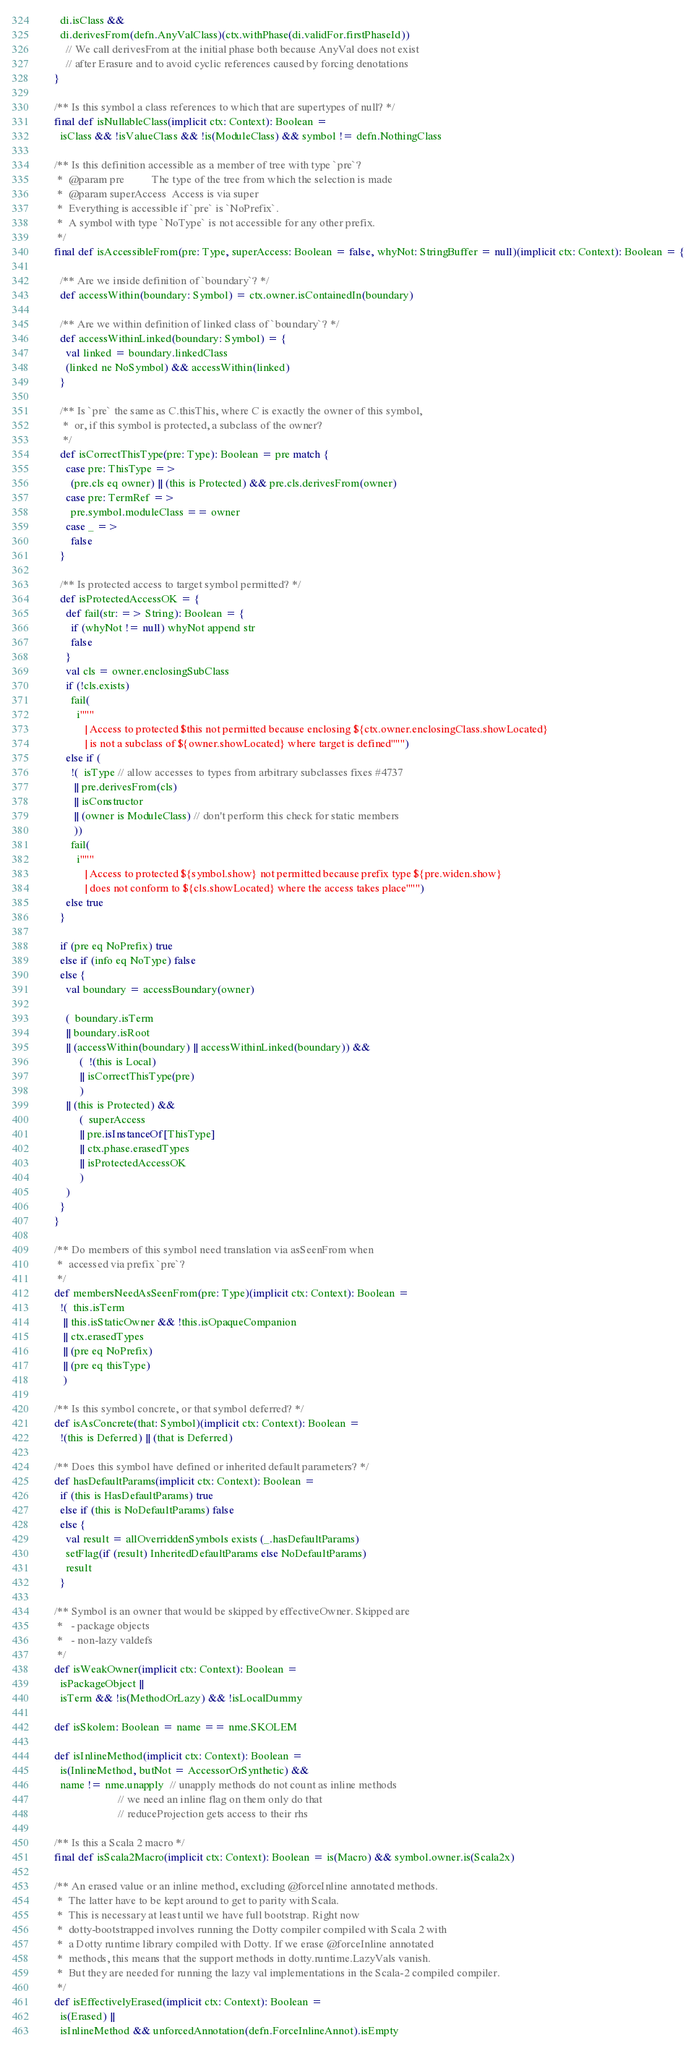Convert code to text. <code><loc_0><loc_0><loc_500><loc_500><_Scala_>      di.isClass &&
      di.derivesFrom(defn.AnyValClass)(ctx.withPhase(di.validFor.firstPhaseId))
        // We call derivesFrom at the initial phase both because AnyVal does not exist
        // after Erasure and to avoid cyclic references caused by forcing denotations
    }

    /** Is this symbol a class references to which that are supertypes of null? */
    final def isNullableClass(implicit ctx: Context): Boolean =
      isClass && !isValueClass && !is(ModuleClass) && symbol != defn.NothingClass

    /** Is this definition accessible as a member of tree with type `pre`?
     *  @param pre          The type of the tree from which the selection is made
     *  @param superAccess  Access is via super
     *  Everything is accessible if `pre` is `NoPrefix`.
     *  A symbol with type `NoType` is not accessible for any other prefix.
     */
    final def isAccessibleFrom(pre: Type, superAccess: Boolean = false, whyNot: StringBuffer = null)(implicit ctx: Context): Boolean = {

      /** Are we inside definition of `boundary`? */
      def accessWithin(boundary: Symbol) = ctx.owner.isContainedIn(boundary)

      /** Are we within definition of linked class of `boundary`? */
      def accessWithinLinked(boundary: Symbol) = {
        val linked = boundary.linkedClass
        (linked ne NoSymbol) && accessWithin(linked)
      }

      /** Is `pre` the same as C.thisThis, where C is exactly the owner of this symbol,
       *  or, if this symbol is protected, a subclass of the owner?
       */
      def isCorrectThisType(pre: Type): Boolean = pre match {
        case pre: ThisType =>
          (pre.cls eq owner) || (this is Protected) && pre.cls.derivesFrom(owner)
        case pre: TermRef =>
          pre.symbol.moduleClass == owner
        case _ =>
          false
      }

      /** Is protected access to target symbol permitted? */
      def isProtectedAccessOK = {
        def fail(str: => String): Boolean = {
          if (whyNot != null) whyNot append str
          false
        }
        val cls = owner.enclosingSubClass
        if (!cls.exists)
          fail(
            i"""
               | Access to protected $this not permitted because enclosing ${ctx.owner.enclosingClass.showLocated}
               | is not a subclass of ${owner.showLocated} where target is defined""")
        else if (
          !(  isType // allow accesses to types from arbitrary subclasses fixes #4737
           || pre.derivesFrom(cls)
           || isConstructor
           || (owner is ModuleClass) // don't perform this check for static members
           ))
          fail(
            i"""
               | Access to protected ${symbol.show} not permitted because prefix type ${pre.widen.show}
               | does not conform to ${cls.showLocated} where the access takes place""")
        else true
      }

      if (pre eq NoPrefix) true
      else if (info eq NoType) false
      else {
        val boundary = accessBoundary(owner)

        (  boundary.isTerm
        || boundary.isRoot
        || (accessWithin(boundary) || accessWithinLinked(boundary)) &&
             (  !(this is Local)
             || isCorrectThisType(pre)
             )
        || (this is Protected) &&
             (  superAccess
             || pre.isInstanceOf[ThisType]
             || ctx.phase.erasedTypes
             || isProtectedAccessOK
             )
        )
      }
    }

    /** Do members of this symbol need translation via asSeenFrom when
     *  accessed via prefix `pre`?
     */
    def membersNeedAsSeenFrom(pre: Type)(implicit ctx: Context): Boolean =
      !(  this.isTerm
       || this.isStaticOwner && !this.isOpaqueCompanion
       || ctx.erasedTypes
       || (pre eq NoPrefix)
       || (pre eq thisType)
       )

    /** Is this symbol concrete, or that symbol deferred? */
    def isAsConcrete(that: Symbol)(implicit ctx: Context): Boolean =
      !(this is Deferred) || (that is Deferred)

    /** Does this symbol have defined or inherited default parameters? */
    def hasDefaultParams(implicit ctx: Context): Boolean =
      if (this is HasDefaultParams) true
      else if (this is NoDefaultParams) false
      else {
        val result = allOverriddenSymbols exists (_.hasDefaultParams)
        setFlag(if (result) InheritedDefaultParams else NoDefaultParams)
        result
      }

    /** Symbol is an owner that would be skipped by effectiveOwner. Skipped are
     *   - package objects
     *   - non-lazy valdefs
     */
    def isWeakOwner(implicit ctx: Context): Boolean =
      isPackageObject ||
      isTerm && !is(MethodOrLazy) && !isLocalDummy

    def isSkolem: Boolean = name == nme.SKOLEM

    def isInlineMethod(implicit ctx: Context): Boolean =
      is(InlineMethod, butNot = AccessorOrSynthetic) &&
      name != nme.unapply  // unapply methods do not count as inline methods
                           // we need an inline flag on them only do that
                           // reduceProjection gets access to their rhs

    /** Is this a Scala 2 macro */
    final def isScala2Macro(implicit ctx: Context): Boolean = is(Macro) && symbol.owner.is(Scala2x)

    /** An erased value or an inline method, excluding @forceInline annotated methods.
     *  The latter have to be kept around to get to parity with Scala.
     *  This is necessary at least until we have full bootstrap. Right now
     *  dotty-bootstrapped involves running the Dotty compiler compiled with Scala 2 with
     *  a Dotty runtime library compiled with Dotty. If we erase @forceInline annotated
     *  methods, this means that the support methods in dotty.runtime.LazyVals vanish.
     *  But they are needed for running the lazy val implementations in the Scala-2 compiled compiler.
     */
    def isEffectivelyErased(implicit ctx: Context): Boolean =
      is(Erased) ||
      isInlineMethod && unforcedAnnotation(defn.ForceInlineAnnot).isEmpty
</code> 